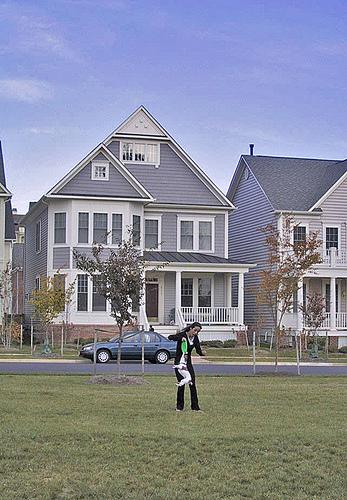How is the dog in midair?

Choices:
A) falling
B) has wings
C) bounced
D) biting frisbee biting frisbee 